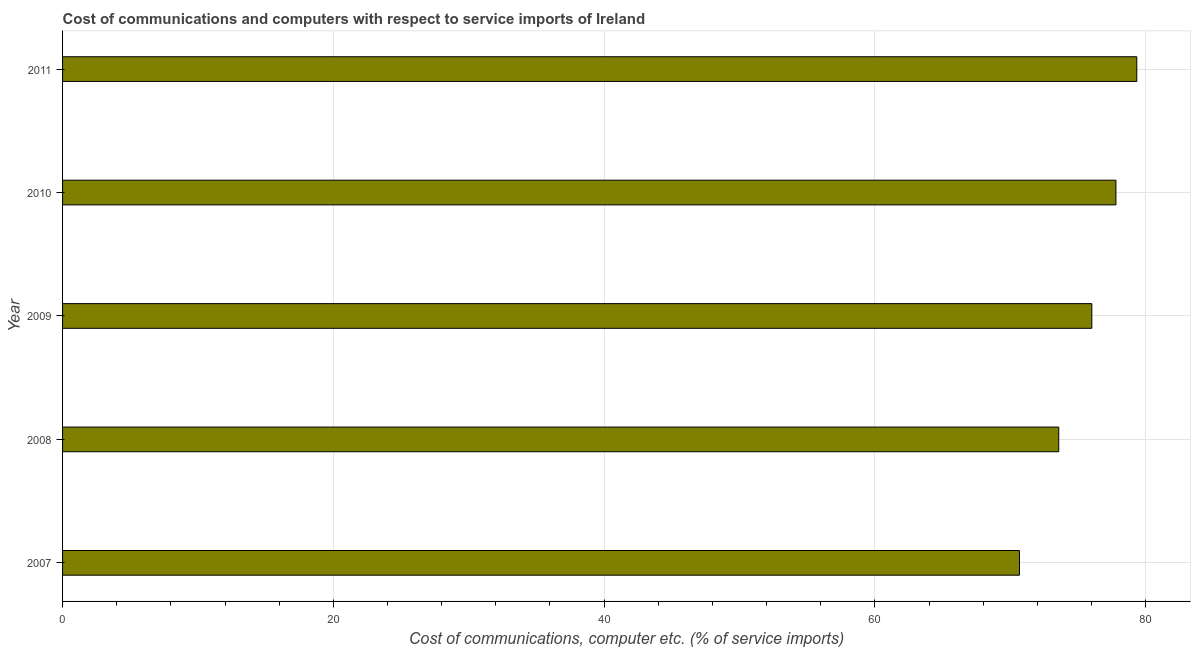Does the graph contain any zero values?
Offer a very short reply. No. What is the title of the graph?
Keep it short and to the point. Cost of communications and computers with respect to service imports of Ireland. What is the label or title of the X-axis?
Offer a very short reply. Cost of communications, computer etc. (% of service imports). What is the cost of communications and computer in 2007?
Ensure brevity in your answer.  70.68. Across all years, what is the maximum cost of communications and computer?
Your answer should be very brief. 79.35. Across all years, what is the minimum cost of communications and computer?
Your answer should be very brief. 70.68. In which year was the cost of communications and computer maximum?
Give a very brief answer. 2011. In which year was the cost of communications and computer minimum?
Offer a terse response. 2007. What is the sum of the cost of communications and computer?
Make the answer very short. 377.44. What is the difference between the cost of communications and computer in 2007 and 2009?
Make the answer very short. -5.34. What is the average cost of communications and computer per year?
Your answer should be compact. 75.49. What is the median cost of communications and computer?
Give a very brief answer. 76.03. In how many years, is the cost of communications and computer greater than 44 %?
Make the answer very short. 5. Do a majority of the years between 2008 and 2009 (inclusive) have cost of communications and computer greater than 4 %?
Keep it short and to the point. Yes. Is the difference between the cost of communications and computer in 2009 and 2010 greater than the difference between any two years?
Offer a very short reply. No. What is the difference between the highest and the second highest cost of communications and computer?
Keep it short and to the point. 1.54. What is the difference between the highest and the lowest cost of communications and computer?
Give a very brief answer. 8.66. In how many years, is the cost of communications and computer greater than the average cost of communications and computer taken over all years?
Give a very brief answer. 3. What is the difference between two consecutive major ticks on the X-axis?
Your response must be concise. 20. What is the Cost of communications, computer etc. (% of service imports) of 2007?
Your response must be concise. 70.68. What is the Cost of communications, computer etc. (% of service imports) in 2008?
Your answer should be very brief. 73.58. What is the Cost of communications, computer etc. (% of service imports) of 2009?
Keep it short and to the point. 76.03. What is the Cost of communications, computer etc. (% of service imports) of 2010?
Provide a succinct answer. 77.81. What is the Cost of communications, computer etc. (% of service imports) of 2011?
Your answer should be very brief. 79.35. What is the difference between the Cost of communications, computer etc. (% of service imports) in 2007 and 2008?
Ensure brevity in your answer.  -2.9. What is the difference between the Cost of communications, computer etc. (% of service imports) in 2007 and 2009?
Offer a very short reply. -5.34. What is the difference between the Cost of communications, computer etc. (% of service imports) in 2007 and 2010?
Give a very brief answer. -7.13. What is the difference between the Cost of communications, computer etc. (% of service imports) in 2007 and 2011?
Offer a terse response. -8.66. What is the difference between the Cost of communications, computer etc. (% of service imports) in 2008 and 2009?
Make the answer very short. -2.44. What is the difference between the Cost of communications, computer etc. (% of service imports) in 2008 and 2010?
Your response must be concise. -4.22. What is the difference between the Cost of communications, computer etc. (% of service imports) in 2008 and 2011?
Ensure brevity in your answer.  -5.76. What is the difference between the Cost of communications, computer etc. (% of service imports) in 2009 and 2010?
Keep it short and to the point. -1.78. What is the difference between the Cost of communications, computer etc. (% of service imports) in 2009 and 2011?
Give a very brief answer. -3.32. What is the difference between the Cost of communications, computer etc. (% of service imports) in 2010 and 2011?
Your answer should be compact. -1.54. What is the ratio of the Cost of communications, computer etc. (% of service imports) in 2007 to that in 2008?
Keep it short and to the point. 0.96. What is the ratio of the Cost of communications, computer etc. (% of service imports) in 2007 to that in 2010?
Give a very brief answer. 0.91. What is the ratio of the Cost of communications, computer etc. (% of service imports) in 2007 to that in 2011?
Offer a terse response. 0.89. What is the ratio of the Cost of communications, computer etc. (% of service imports) in 2008 to that in 2009?
Give a very brief answer. 0.97. What is the ratio of the Cost of communications, computer etc. (% of service imports) in 2008 to that in 2010?
Provide a succinct answer. 0.95. What is the ratio of the Cost of communications, computer etc. (% of service imports) in 2008 to that in 2011?
Keep it short and to the point. 0.93. What is the ratio of the Cost of communications, computer etc. (% of service imports) in 2009 to that in 2011?
Keep it short and to the point. 0.96. What is the ratio of the Cost of communications, computer etc. (% of service imports) in 2010 to that in 2011?
Keep it short and to the point. 0.98. 